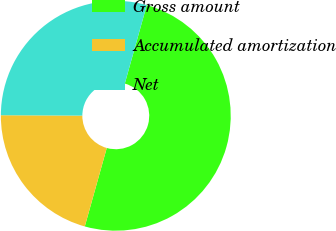Convert chart to OTSL. <chart><loc_0><loc_0><loc_500><loc_500><pie_chart><fcel>Gross amount<fcel>Accumulated amortization<fcel>Net<nl><fcel>50.0%<fcel>20.73%<fcel>29.27%<nl></chart> 